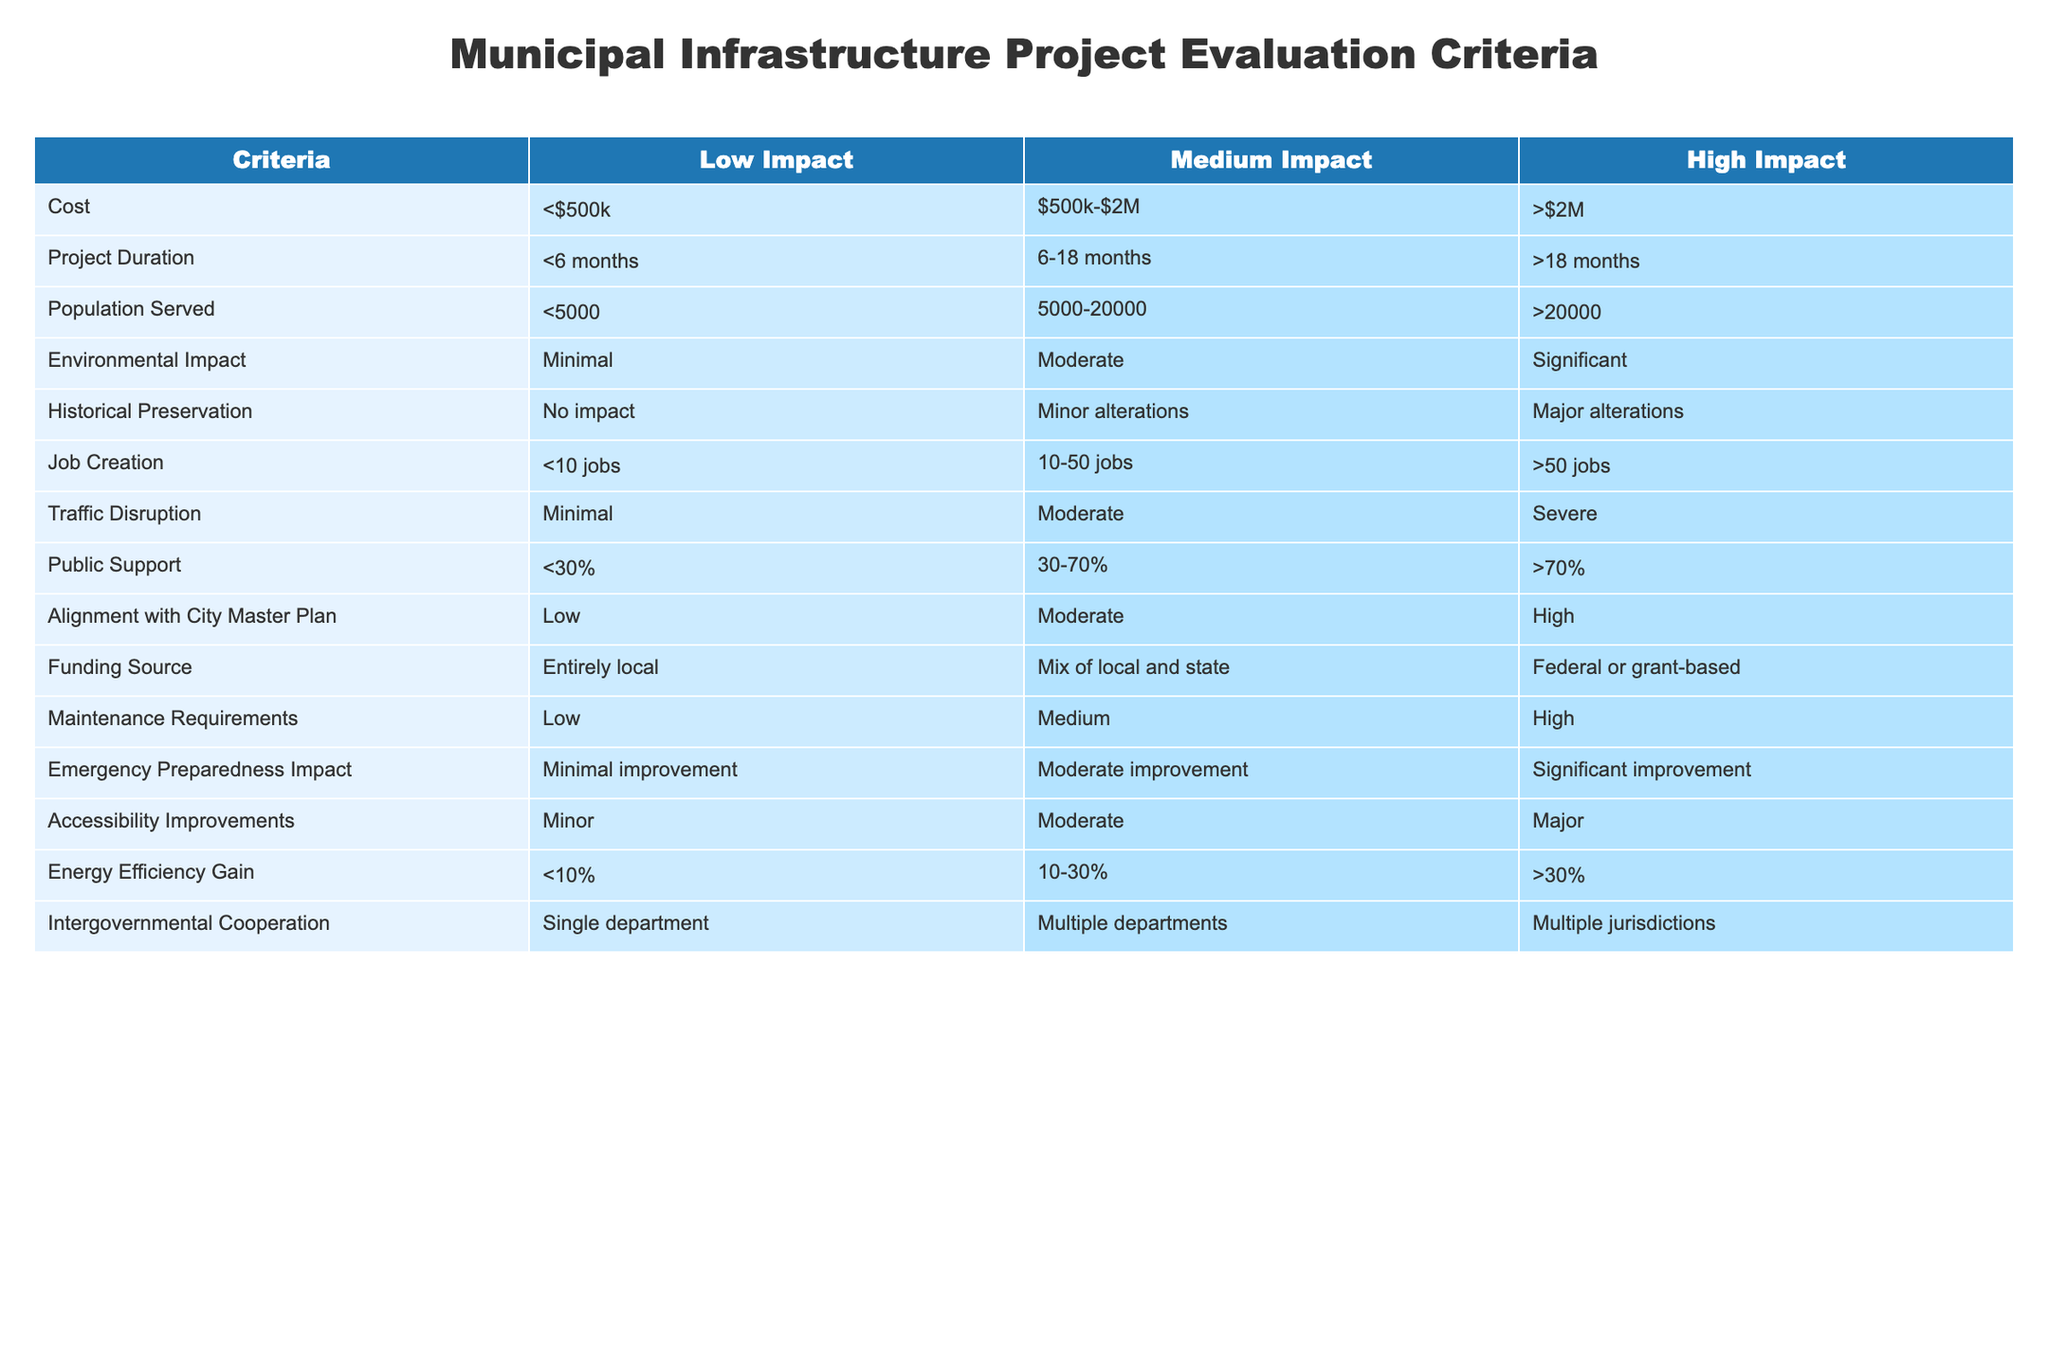What is the cost range for projects classified under "Medium Impact"? According to the table, the cost range for "Medium Impact" projects is defined as $500k-$2M. This information can be directly retrieved from the "Cost" column under the "Medium Impact" category.
Answer: $500k-$2M How many jobs will be created for projects that have "High Impact"? The table shows that for "High Impact" projects, the job creation is categorized as ">50 jobs." This means that such projects will create more than 50 jobs, as referenced in the "Job Creation" column under the corresponding category.
Answer: >50 jobs Is there a significant environmental impact associated with "Low Impact" projects? The table indicates that "Low Impact" projects are associated with "Minimal" environmental impact, as stated in the "Environmental Impact" column. Thus, the answer is no, there is not a significant environmental impact.
Answer: No What is the total range of population served by projects with "Medium Impact"? From the table, "Medium Impact" projects serve a population range of 5000-20000 according to the "Population Served" category. Therefore, the total range of population served is from 5000 to 20000, which is a straightforward retrieval from this category.
Answer: 5000-20000 How does the funding source for projects with "High Impact" differ from those with "Low Impact"? According to the table, "High Impact" projects are funded through "Federal or grant-based" sources, while "Low Impact" projects have funding that is "Entirely local." This indicates a major difference in the sources of funding for these two categories, suggesting different levels of external financial involvement.
Answer: Different sources What is the average energy efficiency gain for all three impact categories? For "Low Impact," the energy efficiency gain is "<10%", for "Medium Impact" it is "10-30%", and for "High Impact" it is ">30%." To find the average efficiency gain, we can convert these ranges into numerical values for approximation: <10% could be approximated as 5%, 10-30% as 20%, and >30% could be approximated as 35%. Now, the average is (5 + 20 + 35) / 3 = 60 / 3 = 20%. Thus, the average energy efficiency gain across the categories is approximately 20%.
Answer: 20% Is there public support above 70% for all "Low Impact" projects? The table specifies that "Low Impact" projects garner "<30%" public support as noted in the "Public Support" column. Since "<30%" is well below 70%, the answer is no; there is not public support above 70% for these projects.
Answer: No What categories of projects result in significant improvement in emergency preparedness? The table suggests that "High Impact" projects lead to "Significant improvement" in emergency preparedness. By looking at the "Emergency Preparedness Impact" column, we can conclude that of the three impact levels, only "High Impact" projects are associated with this degree of improvement. Hence, they represent the category that leads to significant emergency preparedness enhancements.
Answer: High Impact 